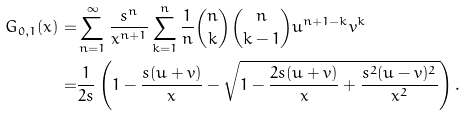<formula> <loc_0><loc_0><loc_500><loc_500>G _ { 0 , 1 } ( x ) = & \sum _ { n = 1 } ^ { \infty } \frac { s ^ { n } } { x ^ { n + 1 } } \sum _ { k = 1 } ^ { n } \frac { 1 } { n } \binom { n } { k } \binom { n } { k - 1 } u ^ { n + 1 - k } v ^ { k } \\ = & \frac { 1 } { 2 s } \left ( 1 - \frac { s ( u + v ) } { x } - \sqrt { 1 - \frac { 2 s ( u + v ) } { x } + \frac { s ^ { 2 } ( u - v ) ^ { 2 } } { x ^ { 2 } } } \right ) .</formula> 